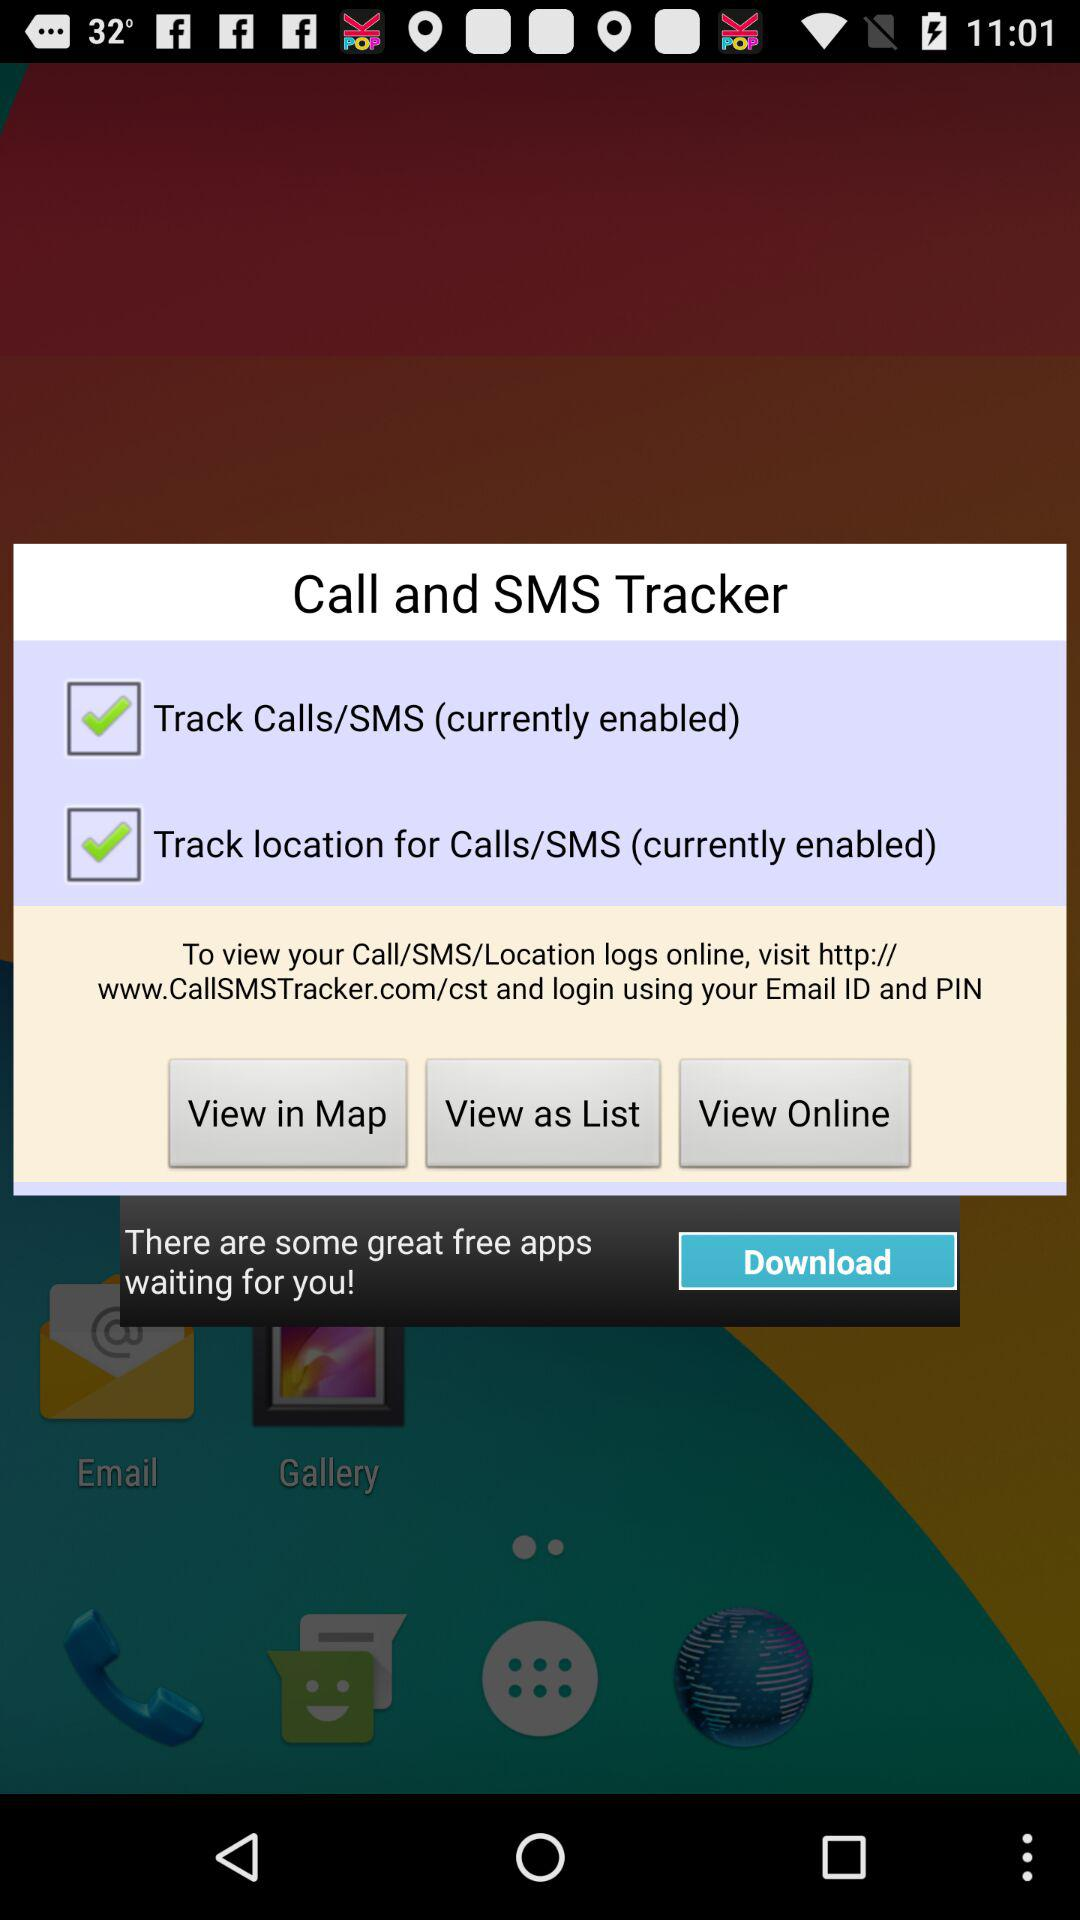What is tracked by "Call and SMS tracker"? The "Call and SMS tracker" will track the calls/SMS and location for calls/SMS. 